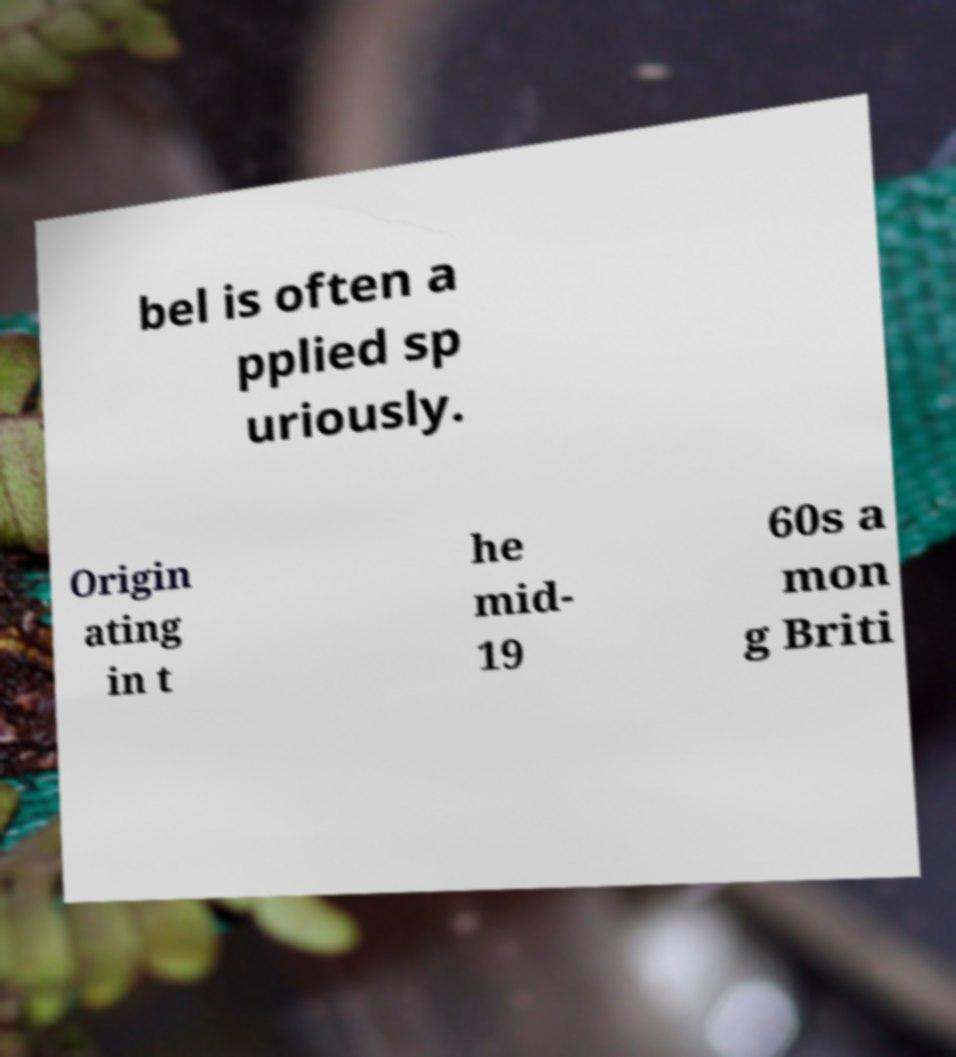Can you accurately transcribe the text from the provided image for me? bel is often a pplied sp uriously. Origin ating in t he mid- 19 60s a mon g Briti 